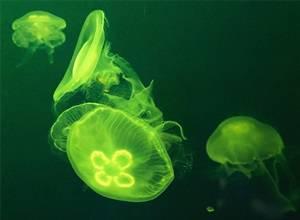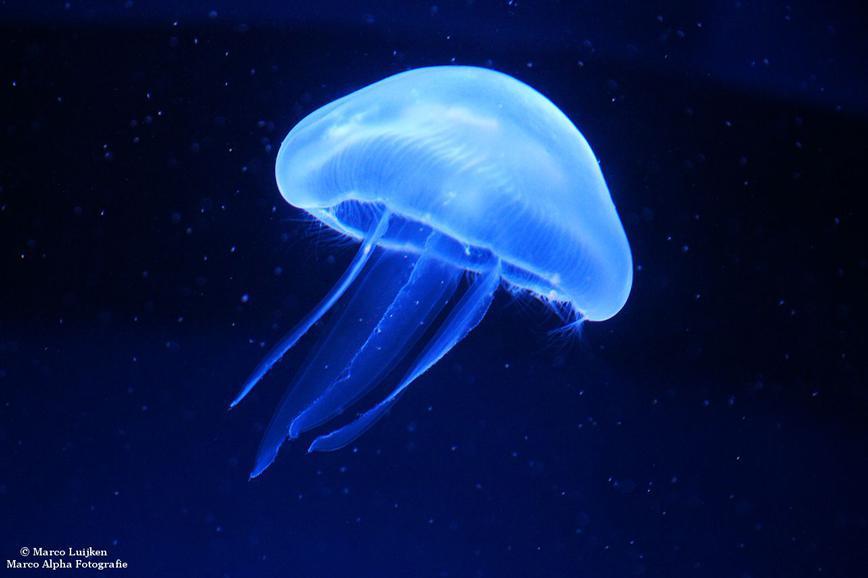The first image is the image on the left, the second image is the image on the right. Assess this claim about the two images: "Right image shows a single mushroom-shaped jellyfish with at least some neon blue tones.". Correct or not? Answer yes or no. Yes. 